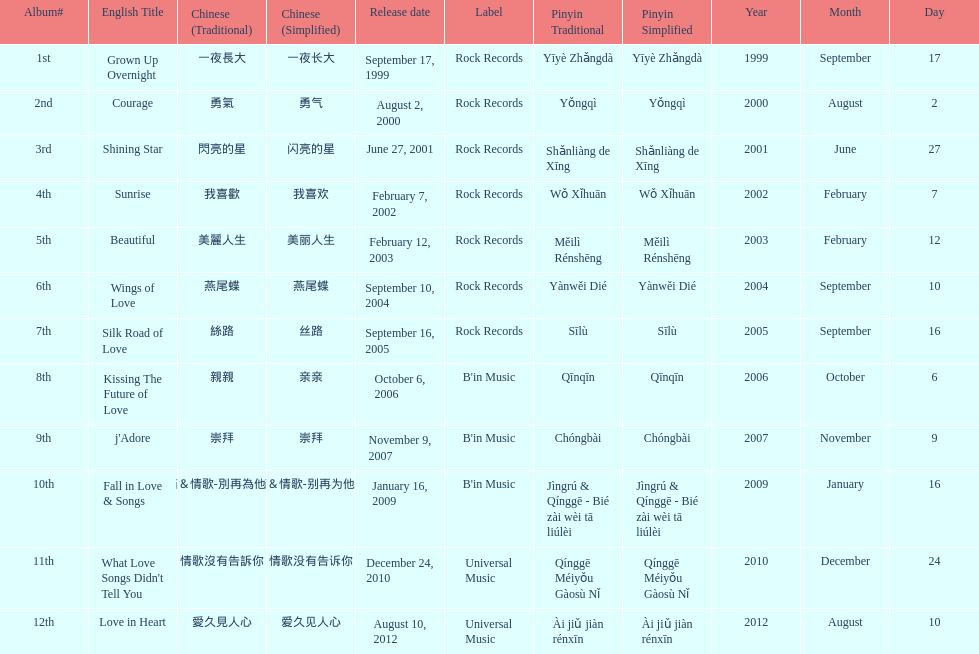What songs were on b'in music or universal music? Kissing The Future of Love, j'Adore, Fall in Love & Songs, What Love Songs Didn't Tell You, Love in Heart. 